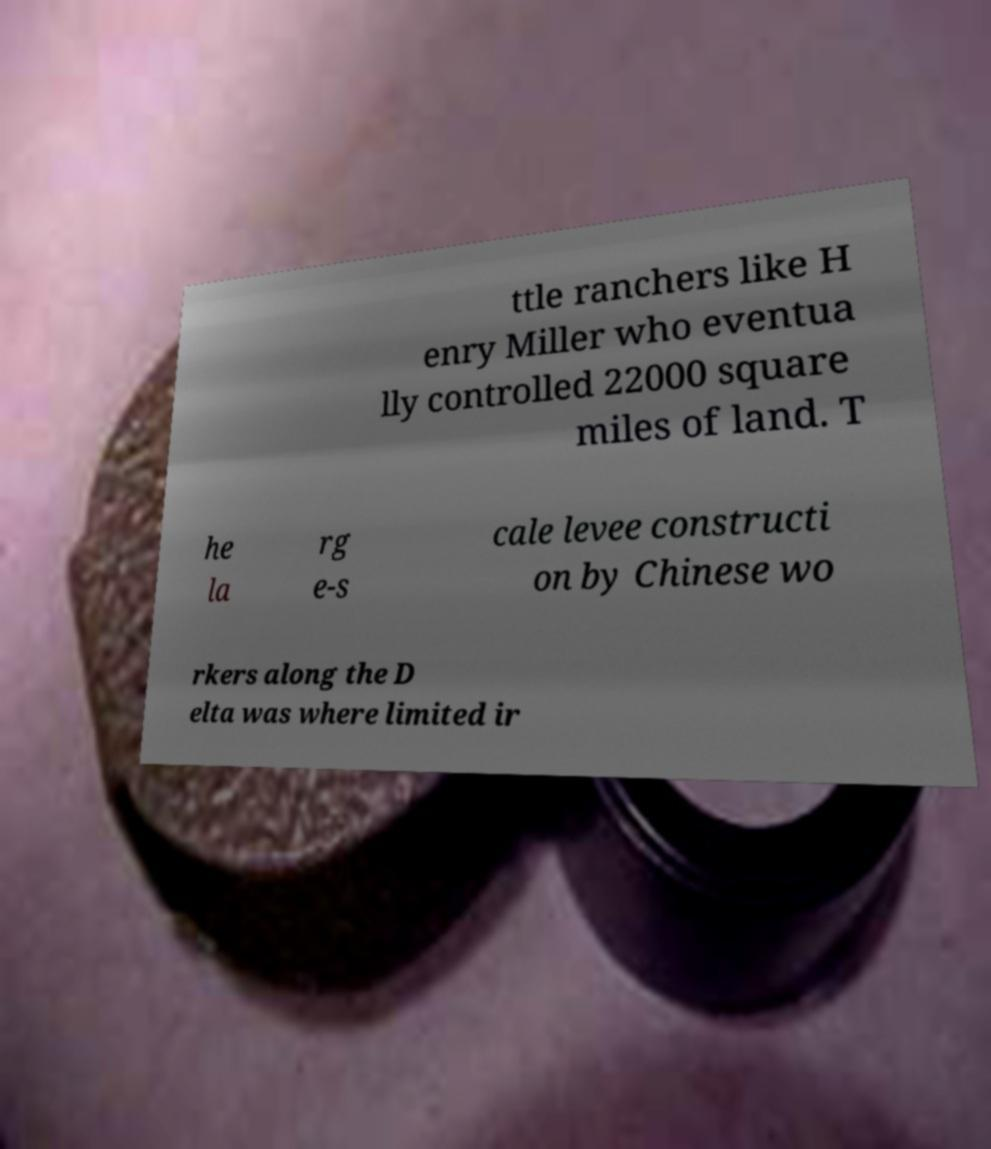What messages or text are displayed in this image? I need them in a readable, typed format. ttle ranchers like H enry Miller who eventua lly controlled 22000 square miles of land. T he la rg e-s cale levee constructi on by Chinese wo rkers along the D elta was where limited ir 